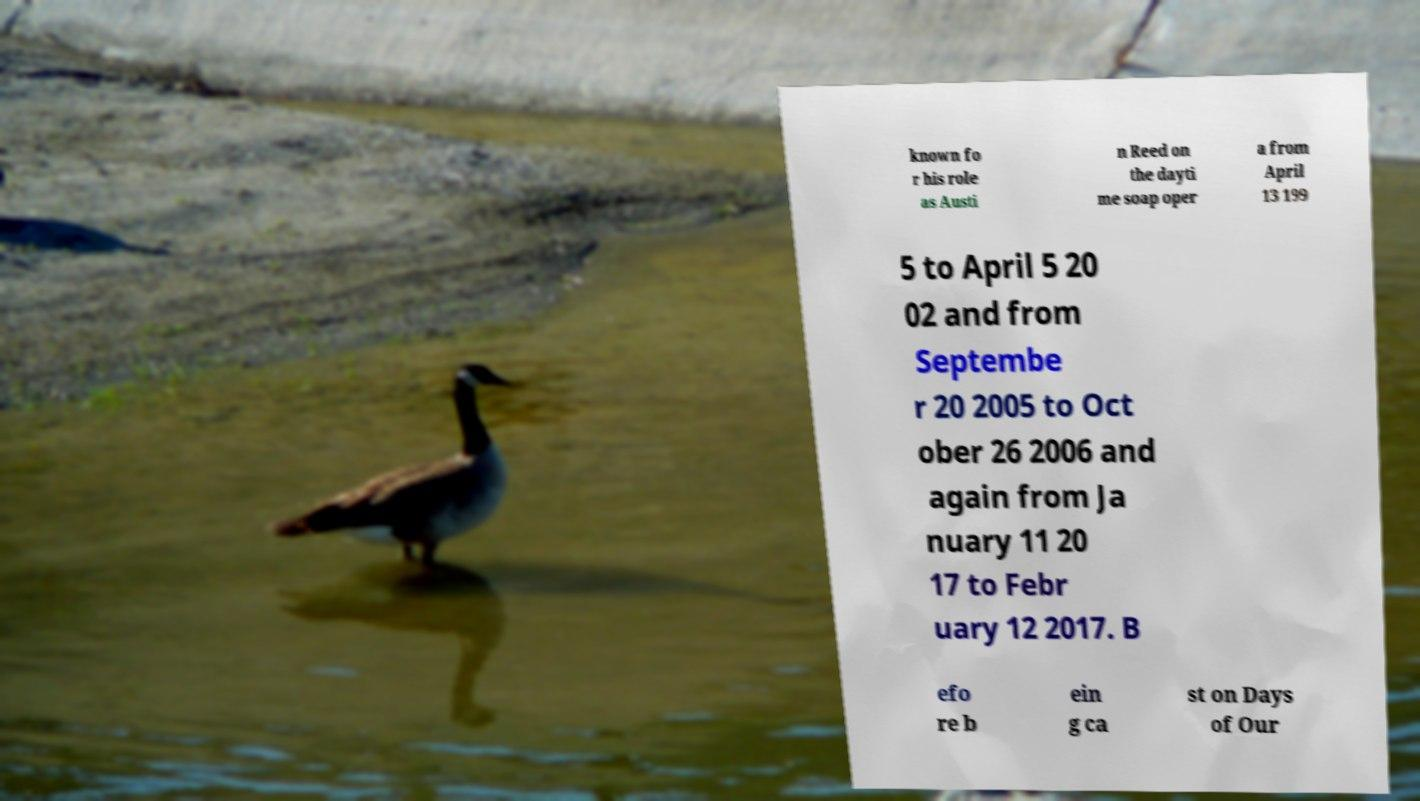There's text embedded in this image that I need extracted. Can you transcribe it verbatim? known fo r his role as Austi n Reed on the dayti me soap oper a from April 13 199 5 to April 5 20 02 and from Septembe r 20 2005 to Oct ober 26 2006 and again from Ja nuary 11 20 17 to Febr uary 12 2017. B efo re b ein g ca st on Days of Our 